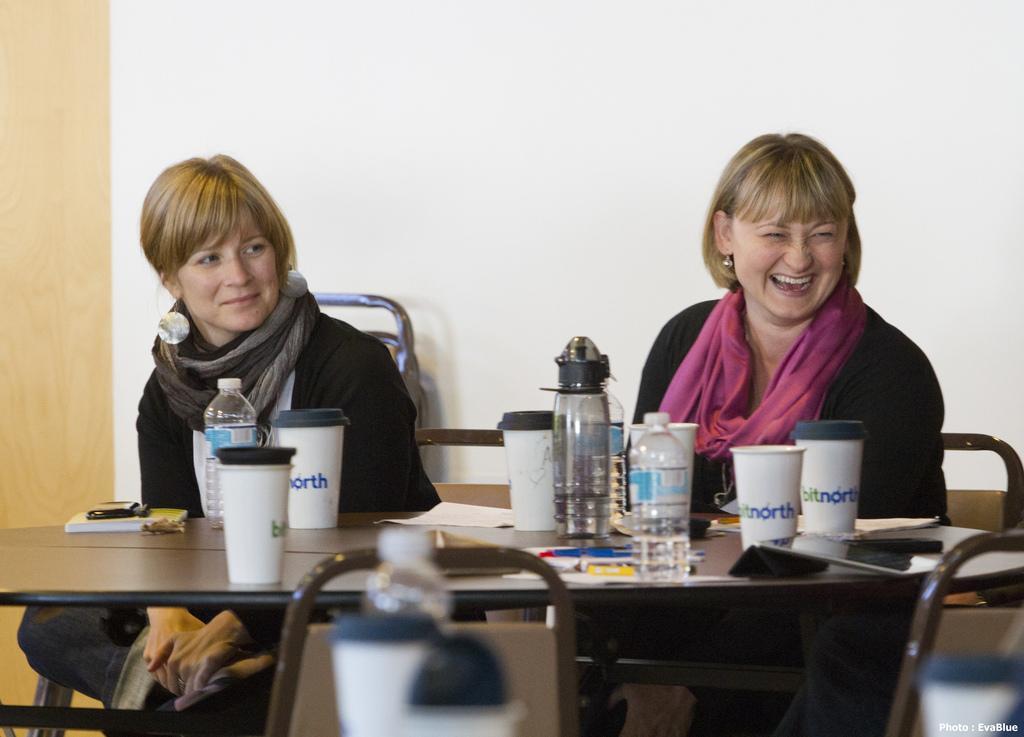Describe this image in one or two sentences. In this image I see 2 women who are sitting on chairs and both of them are smiling, I can see a table in front of them on which there are bottles, cups and other things. In the background I see the wall. 